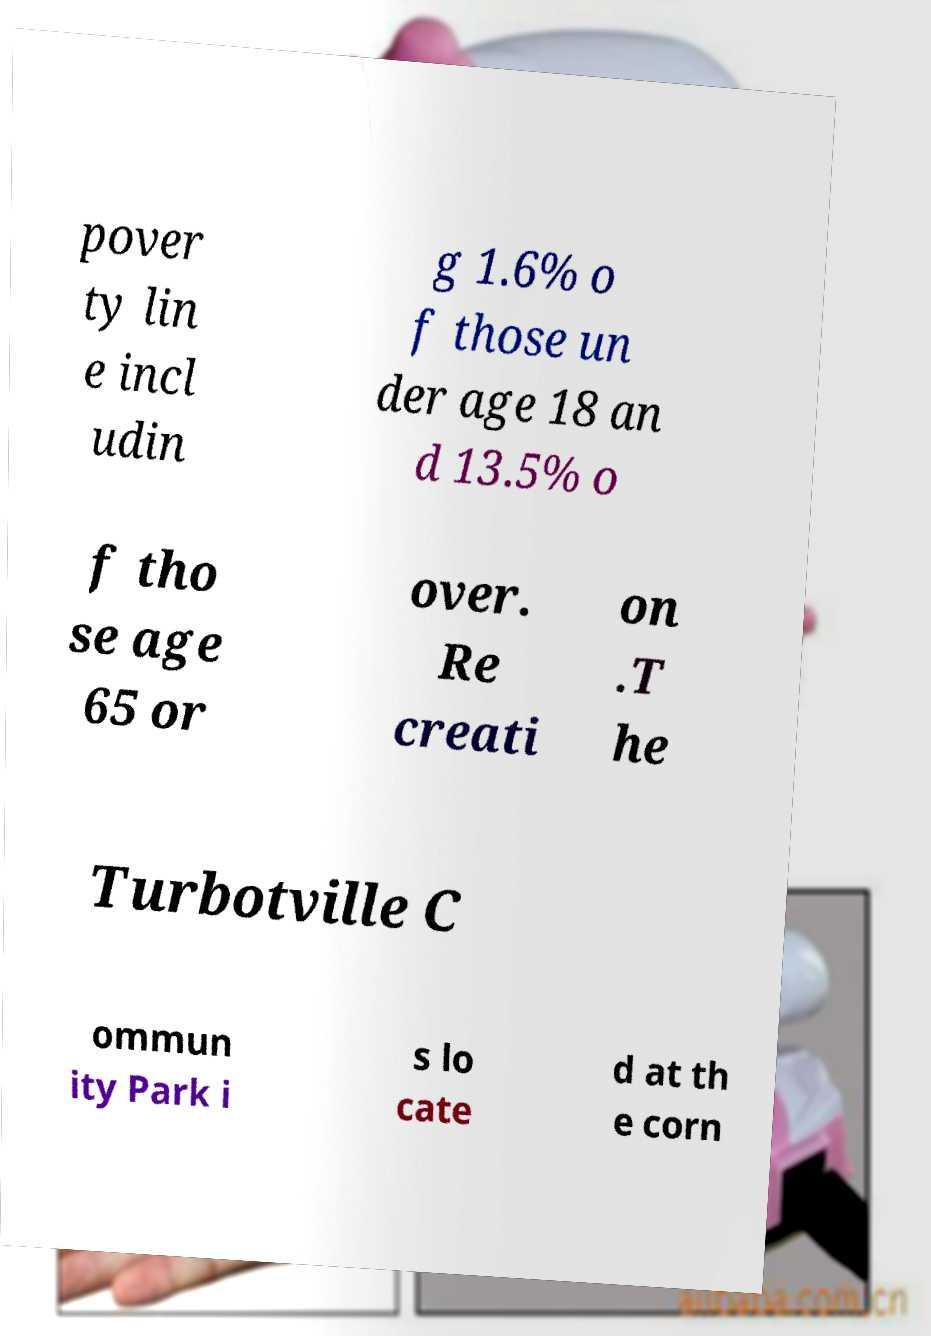Please identify and transcribe the text found in this image. pover ty lin e incl udin g 1.6% o f those un der age 18 an d 13.5% o f tho se age 65 or over. Re creati on .T he Turbotville C ommun ity Park i s lo cate d at th e corn 